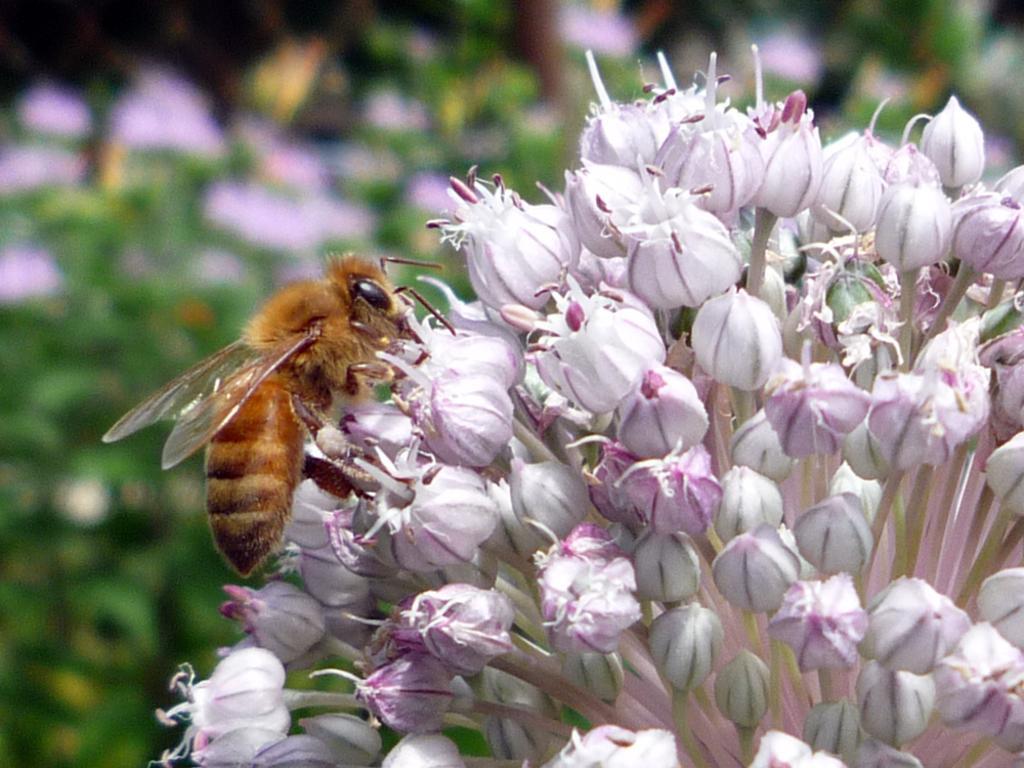Describe this image in one or two sentences. In this image I can see an insect on the flower. I can see few flowers. The background is blurred. 